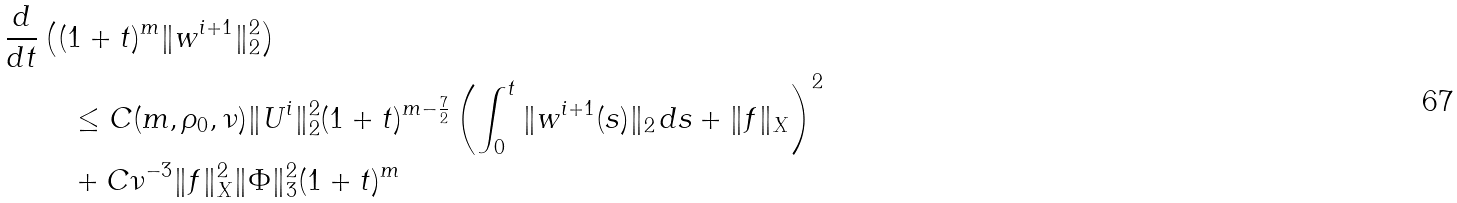Convert formula to latex. <formula><loc_0><loc_0><loc_500><loc_500>\frac { d } { d t } & \left ( ( 1 + t ) ^ { m } \| w ^ { i + 1 } \| _ { 2 } ^ { 2 } \right ) \\ & \quad \leq C ( m , \rho _ { 0 } , \nu ) \| U ^ { i } \| ^ { 2 } _ { 2 } ( 1 + t ) ^ { m - \frac { 7 } { 2 } } \left ( \int _ { 0 } ^ { t } \| w ^ { i + 1 } ( s ) \| _ { 2 } \, d s + \| f \| _ { X } \right ) ^ { 2 } \\ & \quad + C \nu ^ { - 3 } \| f \| _ { X } ^ { 2 } \| \Phi \| _ { 3 } ^ { 2 } ( 1 + t ) ^ { m }</formula> 